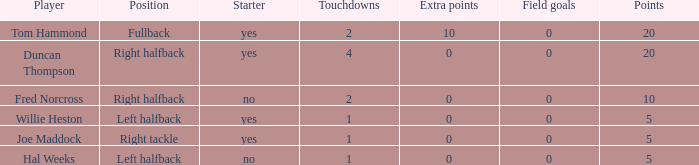What is the highest number of field goals in a situation with more than one touchdown and zero extra points? 0.0. Would you be able to parse every entry in this table? {'header': ['Player', 'Position', 'Starter', 'Touchdowns', 'Extra points', 'Field goals', 'Points'], 'rows': [['Tom Hammond', 'Fullback', 'yes', '2', '10', '0', '20'], ['Duncan Thompson', 'Right halfback', 'yes', '4', '0', '0', '20'], ['Fred Norcross', 'Right halfback', 'no', '2', '0', '0', '10'], ['Willie Heston', 'Left halfback', 'yes', '1', '0', '0', '5'], ['Joe Maddock', 'Right tackle', 'yes', '1', '0', '0', '5'], ['Hal Weeks', 'Left halfback', 'no', '1', '0', '0', '5']]} 